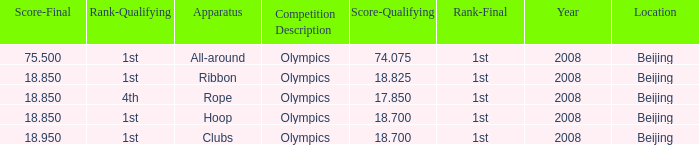Parse the full table. {'header': ['Score-Final', 'Rank-Qualifying', 'Apparatus', 'Competition Description', 'Score-Qualifying', 'Rank-Final', 'Year', 'Location'], 'rows': [['75.500', '1st', 'All-around', 'Olympics', '74.075', '1st', '2008', 'Beijing'], ['18.850', '1st', 'Ribbon', 'Olympics', '18.825', '1st', '2008', 'Beijing'], ['18.850', '4th', 'Rope', 'Olympics', '17.850', '1st', '2008', 'Beijing'], ['18.850', '1st', 'Hoop', 'Olympics', '18.700', '1st', '2008', 'Beijing'], ['18.950', '1st', 'Clubs', 'Olympics', '18.700', '1st', '2008', 'Beijing']]} On which apparatus did Kanayeva have a final score smaller than 75.5 and a qualifying score smaller than 18.7? Rope. 